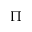<formula> <loc_0><loc_0><loc_500><loc_500>\Pi</formula> 